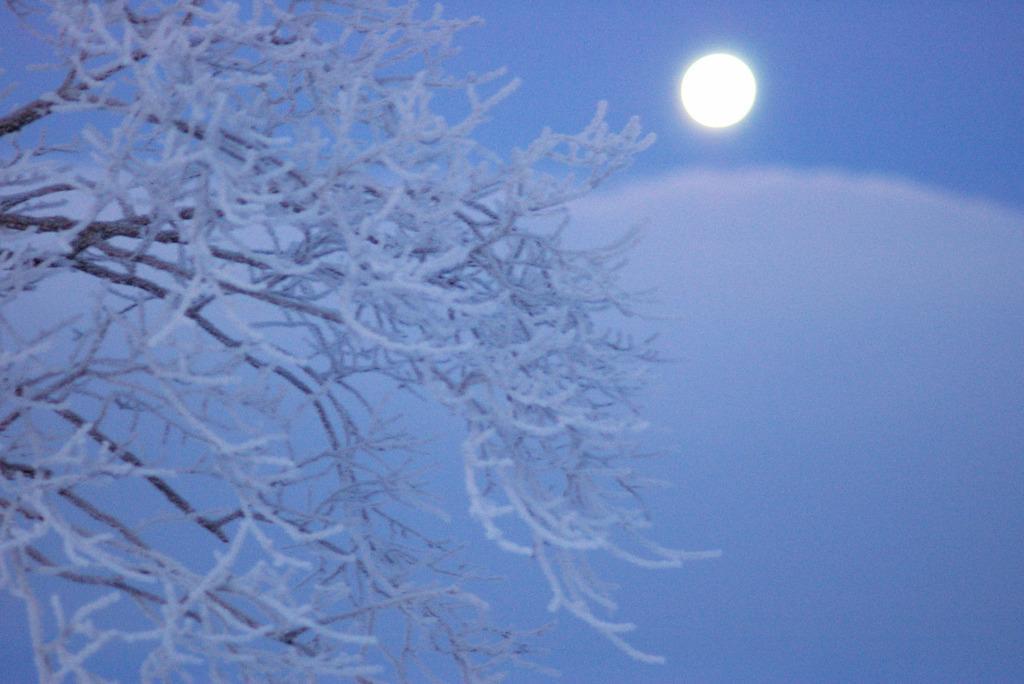Please provide a concise description of this image. In this picture I can see a tree covered with snow, and in the background there is moon in the sky. 